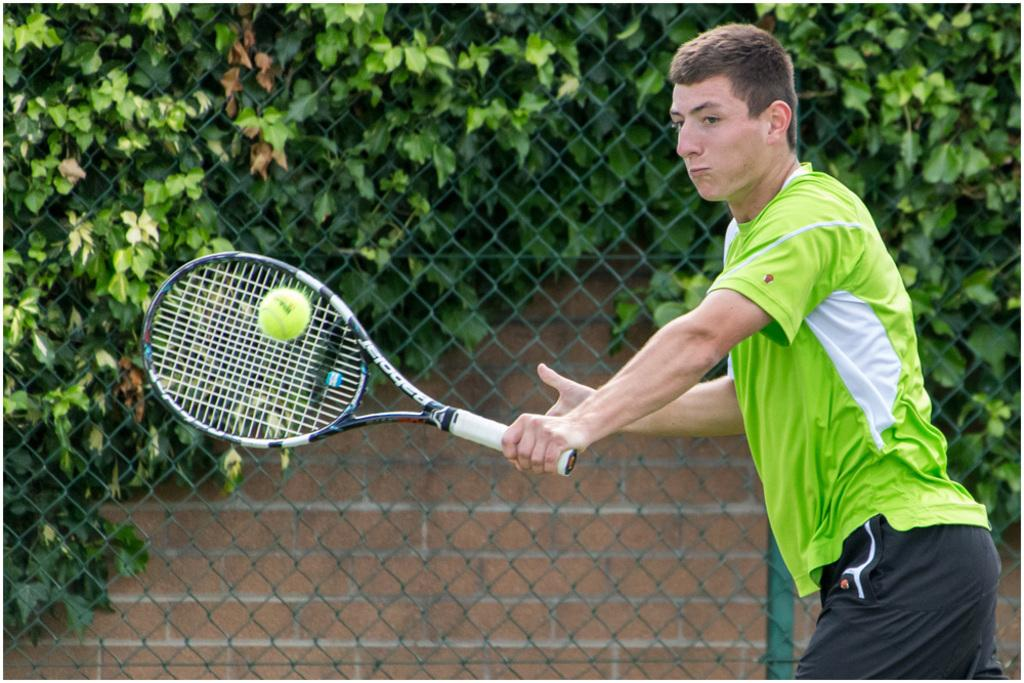What is the man in the image doing? The man is playing tennis in the image. What object is the man using to play tennis? The man is using a bat to play tennis. What can be seen in the background of the image? There are plants visible in the background of the image. What type of barrier is present in the image? There is a metal fence in the image. What type of appliance is the squirrel using to jump in the image? There is no squirrel or appliance present in the image. What season is depicted in the image, considering the presence of plants and the metal fence? The image does not provide enough information to determine the season; it could be any time of year. 